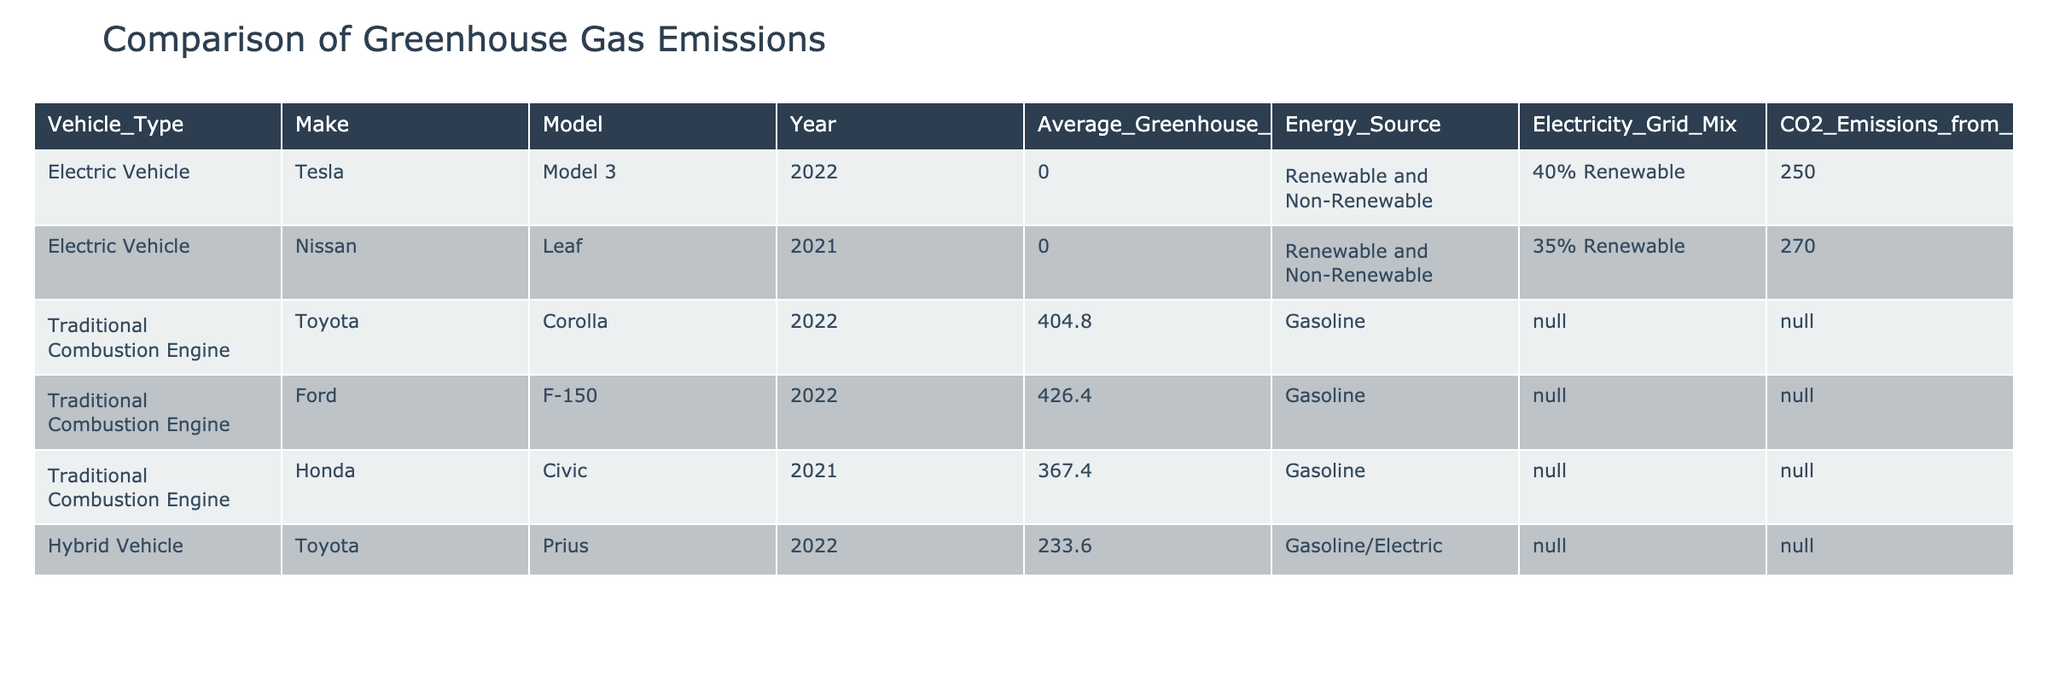What is the average greenhouse gas emissions per mile for the Toyota Corolla? The table shows that the average greenhouse gas emissions for the Toyota Corolla is 404.8 gCO2 per mile as listed under the Traditional Combustion Engine category.
Answer: 404.8 gCO2 per mile How many vehicle types have zero greenhouse gas emissions? The table indicates that both electric vehicle models, the Tesla Model 3 and Nissan Leaf, have zero greenhouse gas emissions per mile, leading to a total of 2 vehicle types with zero emissions.
Answer: 2 What is the difference in average greenhouse gas emissions per mile between the Ford F-150 and the Honda Civic? The average emissions for the Ford F-150 is 426.4 gCO2 per mile and for the Honda Civic it is 367.4 gCO2 per mile. The difference is calculated as 426.4 - 367.4 = 59 gCO2 per mile.
Answer: 59 gCO2 per mile Does the Nissan Leaf use renewable energy sources? The table states that the Nissan Leaf's energy source is "Renewable and Non-Renewable," which implies it indeed utilizes renewable energy, making the statement true.
Answer: Yes What is the average greenhouse gas emissions per mile of all electric vehicles in the table? The two electric vehicles listed are the Tesla Model 3 and Nissan Leaf, both with 0 gCO2 per mile. The average is calculated as (0 + 0) / 2 = 0 gCO2 per mile, as both emissions values are zero.
Answer: 0 gCO2 per mile Which vehicle has the highest average greenhouse gas emissions per mile? Reviewing the data in the table, the Ford F-150 has the highest average emissions at 426.4 gCO2 per mile, compared to the other listed vehicles.
Answer: Ford F-150 If we consider only traditional combustion engines, what are the average emissions across those vehicles? The traditional combustion engines in the table are the Toyota Corolla (404.8), Ford F-150 (426.4), and Honda Civic (367.4). Their average is calculated as (404.8 + 426.4 + 367.4) / 3 = 399.53 gCO2 per mile.
Answer: 399.53 gCO2 per mile Is it accurate to say that electric vehicles contribute to greenhouse gas emissions? Although electric vehicles do not emit greenhouse gases directly (0 gCO2 per mile), their indirect emissions depend on the electricity grid mix, as indicated in the table. Therefore, the statement is true but context-dependent.
Answer: Yes 